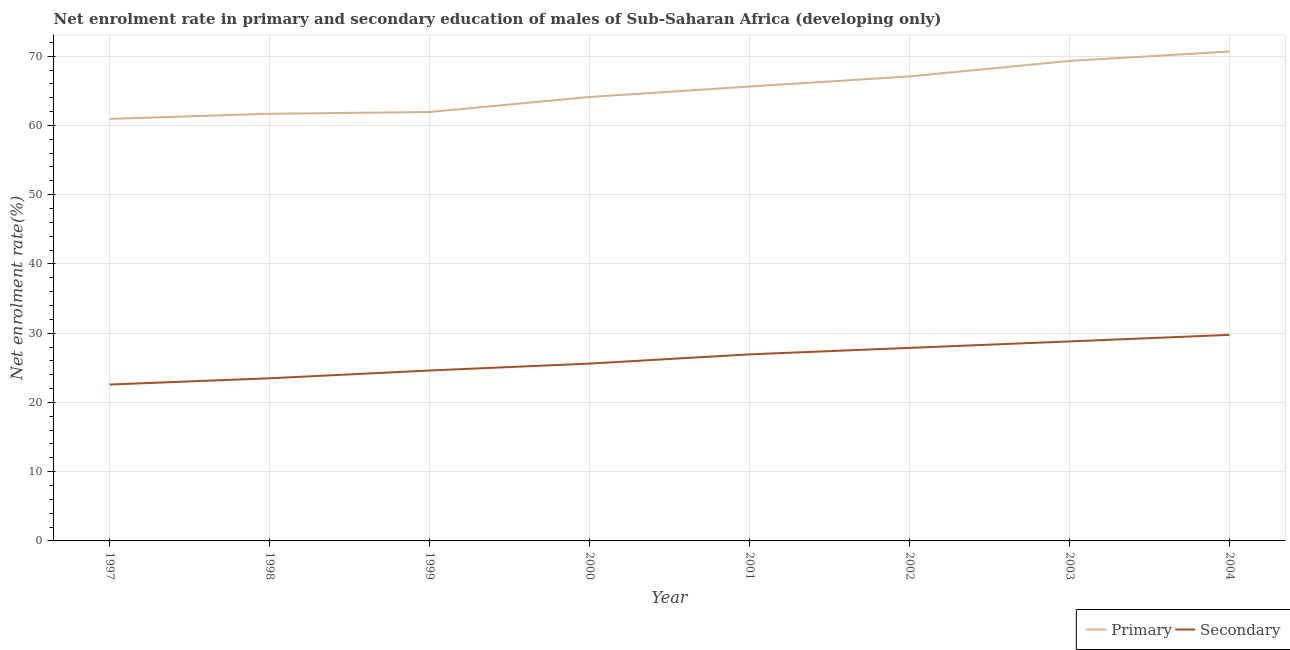How many different coloured lines are there?
Keep it short and to the point. 2. Does the line corresponding to enrollment rate in secondary education intersect with the line corresponding to enrollment rate in primary education?
Provide a short and direct response. No. Is the number of lines equal to the number of legend labels?
Give a very brief answer. Yes. What is the enrollment rate in primary education in 1999?
Offer a terse response. 61.93. Across all years, what is the maximum enrollment rate in primary education?
Ensure brevity in your answer.  70.67. Across all years, what is the minimum enrollment rate in secondary education?
Keep it short and to the point. 22.58. In which year was the enrollment rate in secondary education minimum?
Offer a terse response. 1997. What is the total enrollment rate in primary education in the graph?
Ensure brevity in your answer.  521.33. What is the difference between the enrollment rate in secondary education in 1999 and that in 2001?
Ensure brevity in your answer.  -2.33. What is the difference between the enrollment rate in secondary education in 2003 and the enrollment rate in primary education in 1998?
Offer a terse response. -32.88. What is the average enrollment rate in primary education per year?
Offer a very short reply. 65.17. In the year 2003, what is the difference between the enrollment rate in primary education and enrollment rate in secondary education?
Provide a short and direct response. 40.5. In how many years, is the enrollment rate in primary education greater than 34 %?
Offer a very short reply. 8. What is the ratio of the enrollment rate in secondary education in 2001 to that in 2004?
Provide a succinct answer. 0.91. Is the enrollment rate in primary education in 1997 less than that in 2004?
Provide a succinct answer. Yes. Is the difference between the enrollment rate in primary education in 2001 and 2002 greater than the difference between the enrollment rate in secondary education in 2001 and 2002?
Offer a very short reply. No. What is the difference between the highest and the second highest enrollment rate in secondary education?
Offer a terse response. 0.95. What is the difference between the highest and the lowest enrollment rate in primary education?
Give a very brief answer. 9.73. In how many years, is the enrollment rate in secondary education greater than the average enrollment rate in secondary education taken over all years?
Offer a very short reply. 4. Is the sum of the enrollment rate in secondary education in 2002 and 2004 greater than the maximum enrollment rate in primary education across all years?
Make the answer very short. No. Does the enrollment rate in primary education monotonically increase over the years?
Keep it short and to the point. Yes. Is the enrollment rate in secondary education strictly less than the enrollment rate in primary education over the years?
Provide a short and direct response. Yes. How many lines are there?
Provide a succinct answer. 2. How many years are there in the graph?
Provide a short and direct response. 8. What is the difference between two consecutive major ticks on the Y-axis?
Give a very brief answer. 10. Does the graph contain any zero values?
Your response must be concise. No. Where does the legend appear in the graph?
Ensure brevity in your answer.  Bottom right. What is the title of the graph?
Make the answer very short. Net enrolment rate in primary and secondary education of males of Sub-Saharan Africa (developing only). What is the label or title of the Y-axis?
Your answer should be very brief. Net enrolment rate(%). What is the Net enrolment rate(%) in Primary in 1997?
Keep it short and to the point. 60.94. What is the Net enrolment rate(%) in Secondary in 1997?
Offer a terse response. 22.58. What is the Net enrolment rate(%) of Primary in 1998?
Offer a terse response. 61.68. What is the Net enrolment rate(%) of Secondary in 1998?
Your answer should be very brief. 23.49. What is the Net enrolment rate(%) of Primary in 1999?
Provide a short and direct response. 61.93. What is the Net enrolment rate(%) in Secondary in 1999?
Keep it short and to the point. 24.61. What is the Net enrolment rate(%) of Primary in 2000?
Your answer should be very brief. 64.11. What is the Net enrolment rate(%) in Secondary in 2000?
Ensure brevity in your answer.  25.61. What is the Net enrolment rate(%) in Primary in 2001?
Your answer should be compact. 65.61. What is the Net enrolment rate(%) of Secondary in 2001?
Offer a very short reply. 26.94. What is the Net enrolment rate(%) in Primary in 2002?
Your answer should be very brief. 67.08. What is the Net enrolment rate(%) in Secondary in 2002?
Provide a succinct answer. 27.88. What is the Net enrolment rate(%) in Primary in 2003?
Your response must be concise. 69.31. What is the Net enrolment rate(%) of Secondary in 2003?
Provide a succinct answer. 28.81. What is the Net enrolment rate(%) of Primary in 2004?
Your answer should be very brief. 70.67. What is the Net enrolment rate(%) in Secondary in 2004?
Ensure brevity in your answer.  29.75. Across all years, what is the maximum Net enrolment rate(%) in Primary?
Ensure brevity in your answer.  70.67. Across all years, what is the maximum Net enrolment rate(%) of Secondary?
Your response must be concise. 29.75. Across all years, what is the minimum Net enrolment rate(%) of Primary?
Offer a terse response. 60.94. Across all years, what is the minimum Net enrolment rate(%) of Secondary?
Offer a terse response. 22.58. What is the total Net enrolment rate(%) in Primary in the graph?
Your answer should be very brief. 521.33. What is the total Net enrolment rate(%) in Secondary in the graph?
Your response must be concise. 209.66. What is the difference between the Net enrolment rate(%) in Primary in 1997 and that in 1998?
Ensure brevity in your answer.  -0.74. What is the difference between the Net enrolment rate(%) of Secondary in 1997 and that in 1998?
Keep it short and to the point. -0.9. What is the difference between the Net enrolment rate(%) in Primary in 1997 and that in 1999?
Make the answer very short. -0.99. What is the difference between the Net enrolment rate(%) in Secondary in 1997 and that in 1999?
Offer a terse response. -2.03. What is the difference between the Net enrolment rate(%) in Primary in 1997 and that in 2000?
Offer a very short reply. -3.17. What is the difference between the Net enrolment rate(%) in Secondary in 1997 and that in 2000?
Offer a terse response. -3.02. What is the difference between the Net enrolment rate(%) in Primary in 1997 and that in 2001?
Your answer should be very brief. -4.67. What is the difference between the Net enrolment rate(%) of Secondary in 1997 and that in 2001?
Offer a terse response. -4.36. What is the difference between the Net enrolment rate(%) of Primary in 1997 and that in 2002?
Make the answer very short. -6.14. What is the difference between the Net enrolment rate(%) in Secondary in 1997 and that in 2002?
Offer a terse response. -5.29. What is the difference between the Net enrolment rate(%) of Primary in 1997 and that in 2003?
Offer a terse response. -8.36. What is the difference between the Net enrolment rate(%) in Secondary in 1997 and that in 2003?
Offer a very short reply. -6.22. What is the difference between the Net enrolment rate(%) of Primary in 1997 and that in 2004?
Your answer should be very brief. -9.73. What is the difference between the Net enrolment rate(%) in Secondary in 1997 and that in 2004?
Ensure brevity in your answer.  -7.17. What is the difference between the Net enrolment rate(%) of Primary in 1998 and that in 1999?
Provide a short and direct response. -0.25. What is the difference between the Net enrolment rate(%) of Secondary in 1998 and that in 1999?
Your answer should be very brief. -1.12. What is the difference between the Net enrolment rate(%) of Primary in 1998 and that in 2000?
Give a very brief answer. -2.42. What is the difference between the Net enrolment rate(%) in Secondary in 1998 and that in 2000?
Provide a short and direct response. -2.12. What is the difference between the Net enrolment rate(%) of Primary in 1998 and that in 2001?
Ensure brevity in your answer.  -3.93. What is the difference between the Net enrolment rate(%) in Secondary in 1998 and that in 2001?
Provide a short and direct response. -3.45. What is the difference between the Net enrolment rate(%) in Primary in 1998 and that in 2002?
Make the answer very short. -5.39. What is the difference between the Net enrolment rate(%) of Secondary in 1998 and that in 2002?
Offer a terse response. -4.39. What is the difference between the Net enrolment rate(%) of Primary in 1998 and that in 2003?
Offer a very short reply. -7.62. What is the difference between the Net enrolment rate(%) of Secondary in 1998 and that in 2003?
Make the answer very short. -5.32. What is the difference between the Net enrolment rate(%) of Primary in 1998 and that in 2004?
Your answer should be very brief. -8.98. What is the difference between the Net enrolment rate(%) of Secondary in 1998 and that in 2004?
Make the answer very short. -6.27. What is the difference between the Net enrolment rate(%) of Primary in 1999 and that in 2000?
Make the answer very short. -2.17. What is the difference between the Net enrolment rate(%) of Secondary in 1999 and that in 2000?
Your answer should be very brief. -1. What is the difference between the Net enrolment rate(%) of Primary in 1999 and that in 2001?
Offer a very short reply. -3.68. What is the difference between the Net enrolment rate(%) of Secondary in 1999 and that in 2001?
Make the answer very short. -2.33. What is the difference between the Net enrolment rate(%) of Primary in 1999 and that in 2002?
Provide a short and direct response. -5.14. What is the difference between the Net enrolment rate(%) in Secondary in 1999 and that in 2002?
Ensure brevity in your answer.  -3.27. What is the difference between the Net enrolment rate(%) in Primary in 1999 and that in 2003?
Your answer should be compact. -7.37. What is the difference between the Net enrolment rate(%) in Secondary in 1999 and that in 2003?
Give a very brief answer. -4.2. What is the difference between the Net enrolment rate(%) of Primary in 1999 and that in 2004?
Ensure brevity in your answer.  -8.74. What is the difference between the Net enrolment rate(%) of Secondary in 1999 and that in 2004?
Your answer should be very brief. -5.15. What is the difference between the Net enrolment rate(%) of Primary in 2000 and that in 2001?
Your answer should be very brief. -1.51. What is the difference between the Net enrolment rate(%) in Secondary in 2000 and that in 2001?
Offer a terse response. -1.33. What is the difference between the Net enrolment rate(%) in Primary in 2000 and that in 2002?
Make the answer very short. -2.97. What is the difference between the Net enrolment rate(%) in Secondary in 2000 and that in 2002?
Provide a succinct answer. -2.27. What is the difference between the Net enrolment rate(%) of Primary in 2000 and that in 2003?
Your answer should be very brief. -5.2. What is the difference between the Net enrolment rate(%) of Secondary in 2000 and that in 2003?
Ensure brevity in your answer.  -3.2. What is the difference between the Net enrolment rate(%) of Primary in 2000 and that in 2004?
Your answer should be very brief. -6.56. What is the difference between the Net enrolment rate(%) in Secondary in 2000 and that in 2004?
Ensure brevity in your answer.  -4.15. What is the difference between the Net enrolment rate(%) in Primary in 2001 and that in 2002?
Offer a very short reply. -1.46. What is the difference between the Net enrolment rate(%) in Secondary in 2001 and that in 2002?
Give a very brief answer. -0.94. What is the difference between the Net enrolment rate(%) in Primary in 2001 and that in 2003?
Your response must be concise. -3.69. What is the difference between the Net enrolment rate(%) of Secondary in 2001 and that in 2003?
Offer a very short reply. -1.87. What is the difference between the Net enrolment rate(%) of Primary in 2001 and that in 2004?
Your answer should be very brief. -5.05. What is the difference between the Net enrolment rate(%) of Secondary in 2001 and that in 2004?
Offer a very short reply. -2.81. What is the difference between the Net enrolment rate(%) of Primary in 2002 and that in 2003?
Your response must be concise. -2.23. What is the difference between the Net enrolment rate(%) in Secondary in 2002 and that in 2003?
Your answer should be very brief. -0.93. What is the difference between the Net enrolment rate(%) in Primary in 2002 and that in 2004?
Offer a very short reply. -3.59. What is the difference between the Net enrolment rate(%) in Secondary in 2002 and that in 2004?
Make the answer very short. -1.88. What is the difference between the Net enrolment rate(%) of Primary in 2003 and that in 2004?
Keep it short and to the point. -1.36. What is the difference between the Net enrolment rate(%) in Secondary in 2003 and that in 2004?
Offer a very short reply. -0.95. What is the difference between the Net enrolment rate(%) of Primary in 1997 and the Net enrolment rate(%) of Secondary in 1998?
Offer a very short reply. 37.45. What is the difference between the Net enrolment rate(%) in Primary in 1997 and the Net enrolment rate(%) in Secondary in 1999?
Your answer should be very brief. 36.33. What is the difference between the Net enrolment rate(%) in Primary in 1997 and the Net enrolment rate(%) in Secondary in 2000?
Your answer should be compact. 35.34. What is the difference between the Net enrolment rate(%) of Primary in 1997 and the Net enrolment rate(%) of Secondary in 2001?
Your answer should be compact. 34. What is the difference between the Net enrolment rate(%) of Primary in 1997 and the Net enrolment rate(%) of Secondary in 2002?
Keep it short and to the point. 33.06. What is the difference between the Net enrolment rate(%) in Primary in 1997 and the Net enrolment rate(%) in Secondary in 2003?
Make the answer very short. 32.13. What is the difference between the Net enrolment rate(%) of Primary in 1997 and the Net enrolment rate(%) of Secondary in 2004?
Ensure brevity in your answer.  31.19. What is the difference between the Net enrolment rate(%) in Primary in 1998 and the Net enrolment rate(%) in Secondary in 1999?
Provide a short and direct response. 37.07. What is the difference between the Net enrolment rate(%) in Primary in 1998 and the Net enrolment rate(%) in Secondary in 2000?
Your response must be concise. 36.08. What is the difference between the Net enrolment rate(%) in Primary in 1998 and the Net enrolment rate(%) in Secondary in 2001?
Give a very brief answer. 34.74. What is the difference between the Net enrolment rate(%) in Primary in 1998 and the Net enrolment rate(%) in Secondary in 2002?
Your answer should be very brief. 33.81. What is the difference between the Net enrolment rate(%) in Primary in 1998 and the Net enrolment rate(%) in Secondary in 2003?
Provide a succinct answer. 32.88. What is the difference between the Net enrolment rate(%) in Primary in 1998 and the Net enrolment rate(%) in Secondary in 2004?
Your answer should be compact. 31.93. What is the difference between the Net enrolment rate(%) in Primary in 1999 and the Net enrolment rate(%) in Secondary in 2000?
Your response must be concise. 36.33. What is the difference between the Net enrolment rate(%) in Primary in 1999 and the Net enrolment rate(%) in Secondary in 2001?
Offer a terse response. 34.99. What is the difference between the Net enrolment rate(%) in Primary in 1999 and the Net enrolment rate(%) in Secondary in 2002?
Offer a very short reply. 34.06. What is the difference between the Net enrolment rate(%) of Primary in 1999 and the Net enrolment rate(%) of Secondary in 2003?
Give a very brief answer. 33.13. What is the difference between the Net enrolment rate(%) in Primary in 1999 and the Net enrolment rate(%) in Secondary in 2004?
Provide a short and direct response. 32.18. What is the difference between the Net enrolment rate(%) of Primary in 2000 and the Net enrolment rate(%) of Secondary in 2001?
Ensure brevity in your answer.  37.17. What is the difference between the Net enrolment rate(%) of Primary in 2000 and the Net enrolment rate(%) of Secondary in 2002?
Provide a succinct answer. 36.23. What is the difference between the Net enrolment rate(%) in Primary in 2000 and the Net enrolment rate(%) in Secondary in 2003?
Your response must be concise. 35.3. What is the difference between the Net enrolment rate(%) in Primary in 2000 and the Net enrolment rate(%) in Secondary in 2004?
Your answer should be compact. 34.35. What is the difference between the Net enrolment rate(%) in Primary in 2001 and the Net enrolment rate(%) in Secondary in 2002?
Your answer should be compact. 37.74. What is the difference between the Net enrolment rate(%) of Primary in 2001 and the Net enrolment rate(%) of Secondary in 2003?
Your answer should be very brief. 36.81. What is the difference between the Net enrolment rate(%) in Primary in 2001 and the Net enrolment rate(%) in Secondary in 2004?
Offer a very short reply. 35.86. What is the difference between the Net enrolment rate(%) in Primary in 2002 and the Net enrolment rate(%) in Secondary in 2003?
Provide a succinct answer. 38.27. What is the difference between the Net enrolment rate(%) in Primary in 2002 and the Net enrolment rate(%) in Secondary in 2004?
Ensure brevity in your answer.  37.32. What is the difference between the Net enrolment rate(%) in Primary in 2003 and the Net enrolment rate(%) in Secondary in 2004?
Keep it short and to the point. 39.55. What is the average Net enrolment rate(%) of Primary per year?
Your answer should be very brief. 65.17. What is the average Net enrolment rate(%) of Secondary per year?
Offer a terse response. 26.21. In the year 1997, what is the difference between the Net enrolment rate(%) of Primary and Net enrolment rate(%) of Secondary?
Your answer should be compact. 38.36. In the year 1998, what is the difference between the Net enrolment rate(%) of Primary and Net enrolment rate(%) of Secondary?
Offer a terse response. 38.2. In the year 1999, what is the difference between the Net enrolment rate(%) of Primary and Net enrolment rate(%) of Secondary?
Your response must be concise. 37.32. In the year 2000, what is the difference between the Net enrolment rate(%) of Primary and Net enrolment rate(%) of Secondary?
Your response must be concise. 38.5. In the year 2001, what is the difference between the Net enrolment rate(%) of Primary and Net enrolment rate(%) of Secondary?
Give a very brief answer. 38.68. In the year 2002, what is the difference between the Net enrolment rate(%) of Primary and Net enrolment rate(%) of Secondary?
Your response must be concise. 39.2. In the year 2003, what is the difference between the Net enrolment rate(%) in Primary and Net enrolment rate(%) in Secondary?
Your response must be concise. 40.5. In the year 2004, what is the difference between the Net enrolment rate(%) in Primary and Net enrolment rate(%) in Secondary?
Offer a very short reply. 40.91. What is the ratio of the Net enrolment rate(%) in Secondary in 1997 to that in 1998?
Make the answer very short. 0.96. What is the ratio of the Net enrolment rate(%) in Secondary in 1997 to that in 1999?
Offer a very short reply. 0.92. What is the ratio of the Net enrolment rate(%) in Primary in 1997 to that in 2000?
Keep it short and to the point. 0.95. What is the ratio of the Net enrolment rate(%) in Secondary in 1997 to that in 2000?
Your response must be concise. 0.88. What is the ratio of the Net enrolment rate(%) in Primary in 1997 to that in 2001?
Make the answer very short. 0.93. What is the ratio of the Net enrolment rate(%) of Secondary in 1997 to that in 2001?
Ensure brevity in your answer.  0.84. What is the ratio of the Net enrolment rate(%) in Primary in 1997 to that in 2002?
Offer a very short reply. 0.91. What is the ratio of the Net enrolment rate(%) of Secondary in 1997 to that in 2002?
Keep it short and to the point. 0.81. What is the ratio of the Net enrolment rate(%) of Primary in 1997 to that in 2003?
Offer a terse response. 0.88. What is the ratio of the Net enrolment rate(%) of Secondary in 1997 to that in 2003?
Offer a terse response. 0.78. What is the ratio of the Net enrolment rate(%) in Primary in 1997 to that in 2004?
Your answer should be very brief. 0.86. What is the ratio of the Net enrolment rate(%) of Secondary in 1997 to that in 2004?
Make the answer very short. 0.76. What is the ratio of the Net enrolment rate(%) in Primary in 1998 to that in 1999?
Keep it short and to the point. 1. What is the ratio of the Net enrolment rate(%) of Secondary in 1998 to that in 1999?
Give a very brief answer. 0.95. What is the ratio of the Net enrolment rate(%) in Primary in 1998 to that in 2000?
Offer a very short reply. 0.96. What is the ratio of the Net enrolment rate(%) of Secondary in 1998 to that in 2000?
Offer a terse response. 0.92. What is the ratio of the Net enrolment rate(%) in Primary in 1998 to that in 2001?
Your answer should be very brief. 0.94. What is the ratio of the Net enrolment rate(%) in Secondary in 1998 to that in 2001?
Offer a terse response. 0.87. What is the ratio of the Net enrolment rate(%) of Primary in 1998 to that in 2002?
Offer a terse response. 0.92. What is the ratio of the Net enrolment rate(%) of Secondary in 1998 to that in 2002?
Your answer should be compact. 0.84. What is the ratio of the Net enrolment rate(%) of Primary in 1998 to that in 2003?
Offer a very short reply. 0.89. What is the ratio of the Net enrolment rate(%) in Secondary in 1998 to that in 2003?
Keep it short and to the point. 0.82. What is the ratio of the Net enrolment rate(%) in Primary in 1998 to that in 2004?
Provide a short and direct response. 0.87. What is the ratio of the Net enrolment rate(%) of Secondary in 1998 to that in 2004?
Your answer should be very brief. 0.79. What is the ratio of the Net enrolment rate(%) in Primary in 1999 to that in 2000?
Make the answer very short. 0.97. What is the ratio of the Net enrolment rate(%) in Secondary in 1999 to that in 2000?
Offer a very short reply. 0.96. What is the ratio of the Net enrolment rate(%) of Primary in 1999 to that in 2001?
Your answer should be very brief. 0.94. What is the ratio of the Net enrolment rate(%) in Secondary in 1999 to that in 2001?
Provide a short and direct response. 0.91. What is the ratio of the Net enrolment rate(%) of Primary in 1999 to that in 2002?
Make the answer very short. 0.92. What is the ratio of the Net enrolment rate(%) of Secondary in 1999 to that in 2002?
Your response must be concise. 0.88. What is the ratio of the Net enrolment rate(%) in Primary in 1999 to that in 2003?
Your answer should be compact. 0.89. What is the ratio of the Net enrolment rate(%) in Secondary in 1999 to that in 2003?
Your answer should be very brief. 0.85. What is the ratio of the Net enrolment rate(%) in Primary in 1999 to that in 2004?
Keep it short and to the point. 0.88. What is the ratio of the Net enrolment rate(%) of Secondary in 1999 to that in 2004?
Offer a terse response. 0.83. What is the ratio of the Net enrolment rate(%) of Secondary in 2000 to that in 2001?
Your response must be concise. 0.95. What is the ratio of the Net enrolment rate(%) in Primary in 2000 to that in 2002?
Make the answer very short. 0.96. What is the ratio of the Net enrolment rate(%) of Secondary in 2000 to that in 2002?
Ensure brevity in your answer.  0.92. What is the ratio of the Net enrolment rate(%) of Primary in 2000 to that in 2003?
Offer a terse response. 0.93. What is the ratio of the Net enrolment rate(%) in Primary in 2000 to that in 2004?
Give a very brief answer. 0.91. What is the ratio of the Net enrolment rate(%) in Secondary in 2000 to that in 2004?
Offer a very short reply. 0.86. What is the ratio of the Net enrolment rate(%) of Primary in 2001 to that in 2002?
Offer a terse response. 0.98. What is the ratio of the Net enrolment rate(%) in Secondary in 2001 to that in 2002?
Give a very brief answer. 0.97. What is the ratio of the Net enrolment rate(%) of Primary in 2001 to that in 2003?
Give a very brief answer. 0.95. What is the ratio of the Net enrolment rate(%) in Secondary in 2001 to that in 2003?
Your answer should be very brief. 0.94. What is the ratio of the Net enrolment rate(%) in Primary in 2001 to that in 2004?
Your response must be concise. 0.93. What is the ratio of the Net enrolment rate(%) in Secondary in 2001 to that in 2004?
Keep it short and to the point. 0.91. What is the ratio of the Net enrolment rate(%) in Primary in 2002 to that in 2003?
Your response must be concise. 0.97. What is the ratio of the Net enrolment rate(%) in Primary in 2002 to that in 2004?
Provide a succinct answer. 0.95. What is the ratio of the Net enrolment rate(%) in Secondary in 2002 to that in 2004?
Offer a terse response. 0.94. What is the ratio of the Net enrolment rate(%) in Primary in 2003 to that in 2004?
Keep it short and to the point. 0.98. What is the ratio of the Net enrolment rate(%) in Secondary in 2003 to that in 2004?
Your answer should be compact. 0.97. What is the difference between the highest and the second highest Net enrolment rate(%) of Primary?
Give a very brief answer. 1.36. What is the difference between the highest and the second highest Net enrolment rate(%) in Secondary?
Provide a succinct answer. 0.95. What is the difference between the highest and the lowest Net enrolment rate(%) of Primary?
Your answer should be compact. 9.73. What is the difference between the highest and the lowest Net enrolment rate(%) of Secondary?
Make the answer very short. 7.17. 